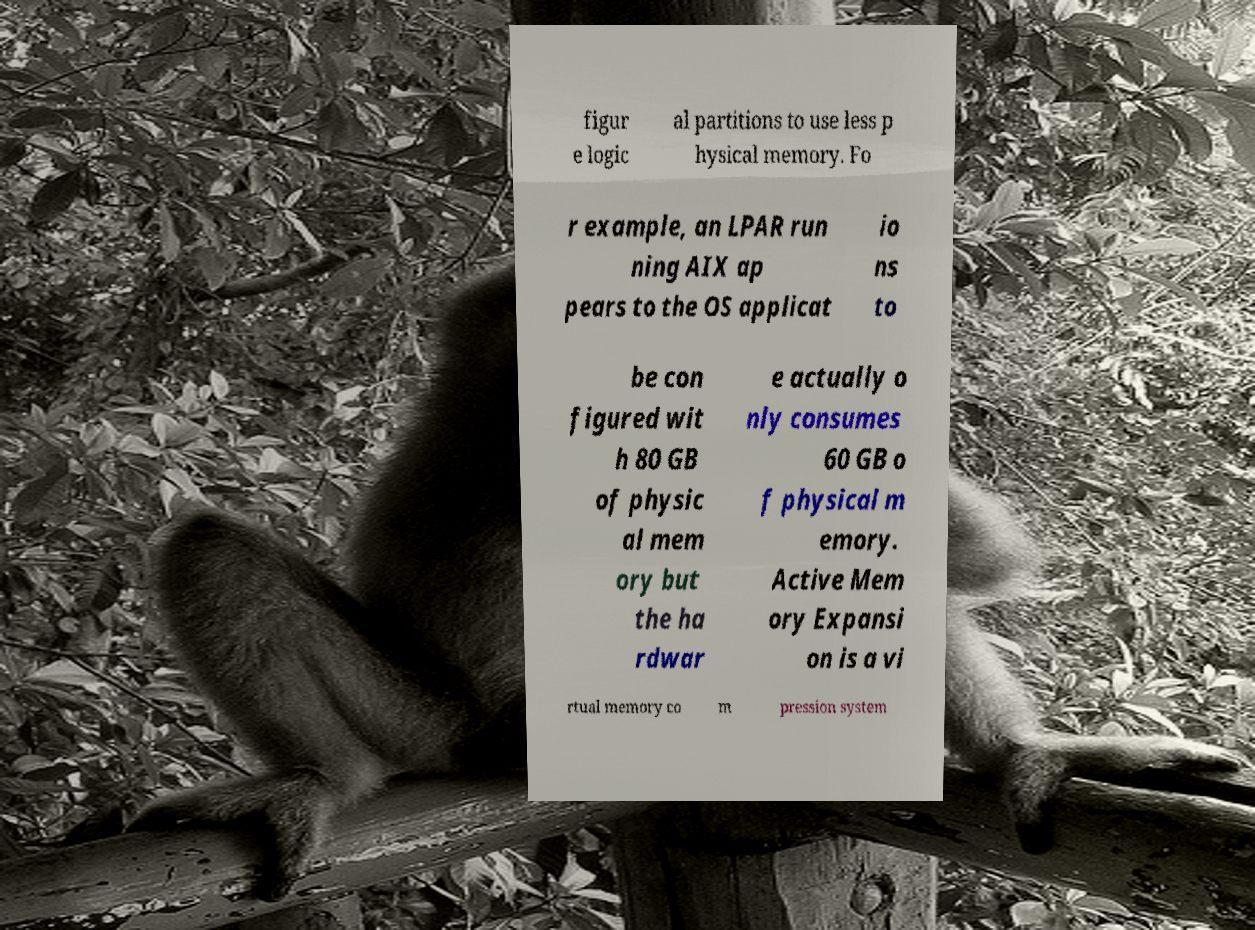Please read and relay the text visible in this image. What does it say? figur e logic al partitions to use less p hysical memory. Fo r example, an LPAR run ning AIX ap pears to the OS applicat io ns to be con figured wit h 80 GB of physic al mem ory but the ha rdwar e actually o nly consumes 60 GB o f physical m emory. Active Mem ory Expansi on is a vi rtual memory co m pression system 